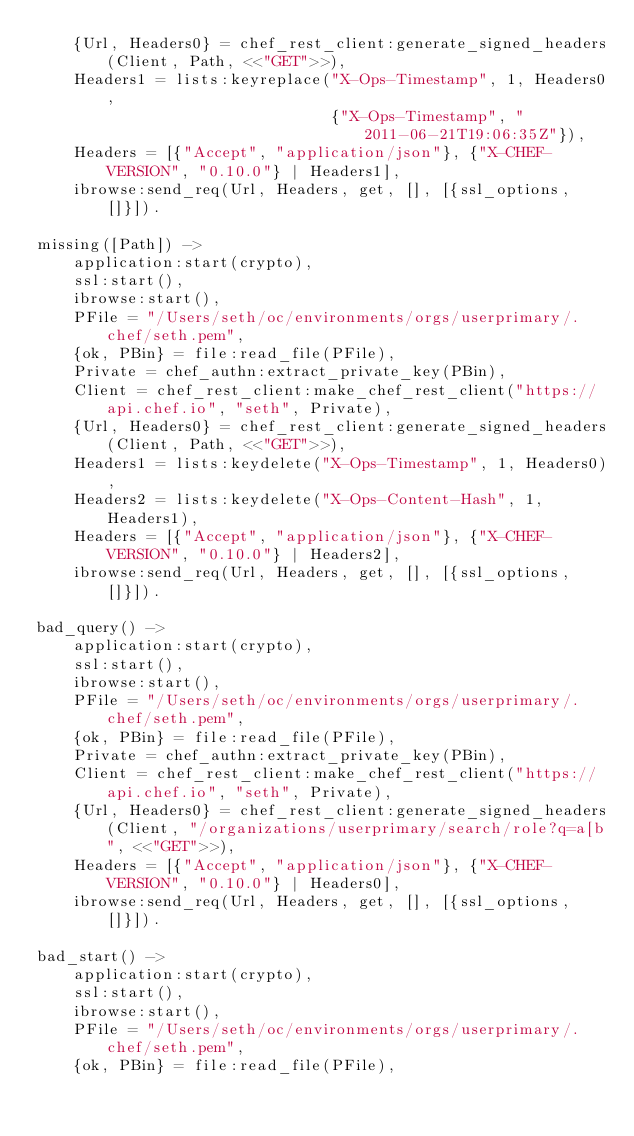Convert code to text. <code><loc_0><loc_0><loc_500><loc_500><_Erlang_>    {Url, Headers0} = chef_rest_client:generate_signed_headers(Client, Path, <<"GET">>),
    Headers1 = lists:keyreplace("X-Ops-Timestamp", 1, Headers0,
                                {"X-Ops-Timestamp", "2011-06-21T19:06:35Z"}),
    Headers = [{"Accept", "application/json"}, {"X-CHEF-VERSION", "0.10.0"} | Headers1],
    ibrowse:send_req(Url, Headers, get, [], [{ssl_options, []}]).

missing([Path]) ->
    application:start(crypto),
    ssl:start(),
    ibrowse:start(),
    PFile = "/Users/seth/oc/environments/orgs/userprimary/.chef/seth.pem",
    {ok, PBin} = file:read_file(PFile),
    Private = chef_authn:extract_private_key(PBin),
    Client = chef_rest_client:make_chef_rest_client("https://api.chef.io", "seth", Private),
    {Url, Headers0} = chef_rest_client:generate_signed_headers(Client, Path, <<"GET">>),
    Headers1 = lists:keydelete("X-Ops-Timestamp", 1, Headers0),
    Headers2 = lists:keydelete("X-Ops-Content-Hash", 1, Headers1),
    Headers = [{"Accept", "application/json"}, {"X-CHEF-VERSION", "0.10.0"} | Headers2],
    ibrowse:send_req(Url, Headers, get, [], [{ssl_options, []}]).
    
bad_query() ->
    application:start(crypto),
    ssl:start(),
    ibrowse:start(),
    PFile = "/Users/seth/oc/environments/orgs/userprimary/.chef/seth.pem",
    {ok, PBin} = file:read_file(PFile),
    Private = chef_authn:extract_private_key(PBin),
    Client = chef_rest_client:make_chef_rest_client("https://api.chef.io", "seth", Private),
    {Url, Headers0} = chef_rest_client:generate_signed_headers(Client, "/organizations/userprimary/search/role?q=a[b", <<"GET">>),
    Headers = [{"Accept", "application/json"}, {"X-CHEF-VERSION", "0.10.0"} | Headers0],
    ibrowse:send_req(Url, Headers, get, [], [{ssl_options, []}]).

bad_start() ->
    application:start(crypto),
    ssl:start(),
    ibrowse:start(),
    PFile = "/Users/seth/oc/environments/orgs/userprimary/.chef/seth.pem",
    {ok, PBin} = file:read_file(PFile),</code> 